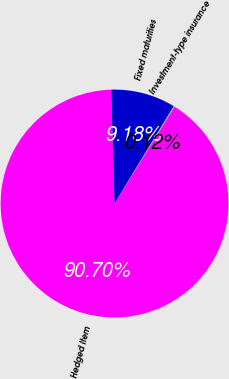<chart> <loc_0><loc_0><loc_500><loc_500><pie_chart><fcel>Hedged Item<fcel>Fixed maturities<fcel>Investment-type insurance<nl><fcel>90.7%<fcel>9.18%<fcel>0.12%<nl></chart> 